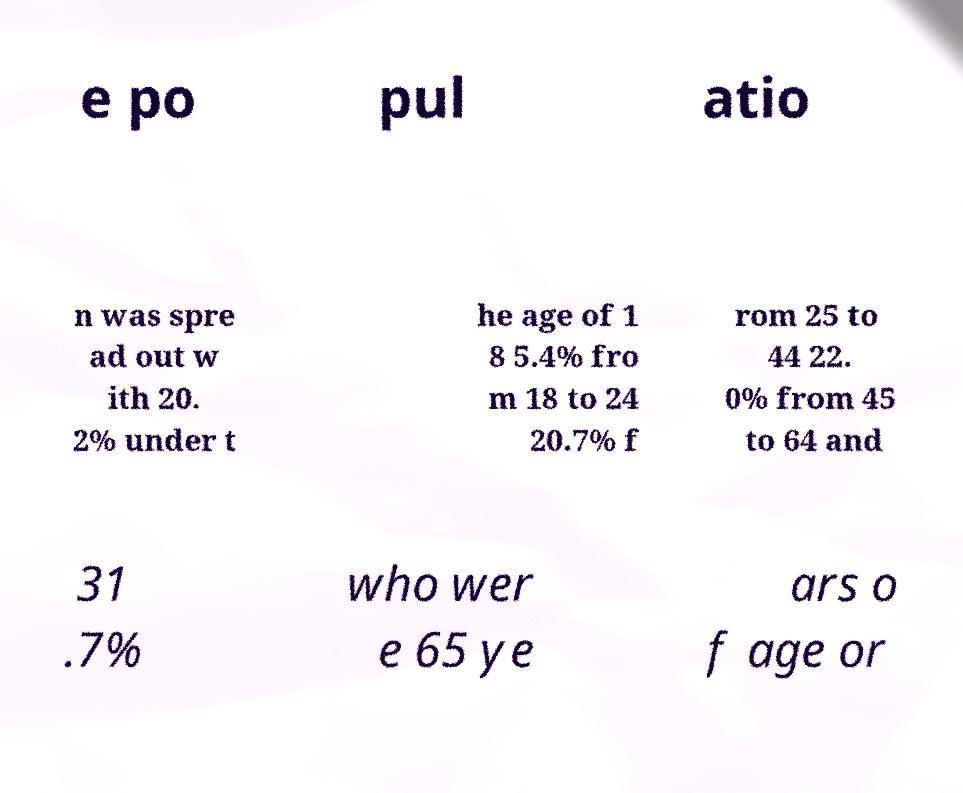Can you accurately transcribe the text from the provided image for me? e po pul atio n was spre ad out w ith 20. 2% under t he age of 1 8 5.4% fro m 18 to 24 20.7% f rom 25 to 44 22. 0% from 45 to 64 and 31 .7% who wer e 65 ye ars o f age or 